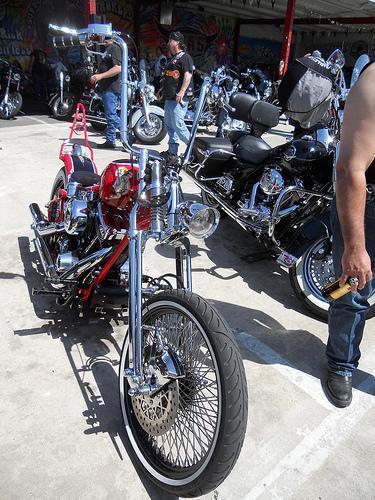How many people are in the photo?
Give a very brief answer. 3. How many wheels does the motorcycle on the left in the foreground have?
Give a very brief answer. 2. 